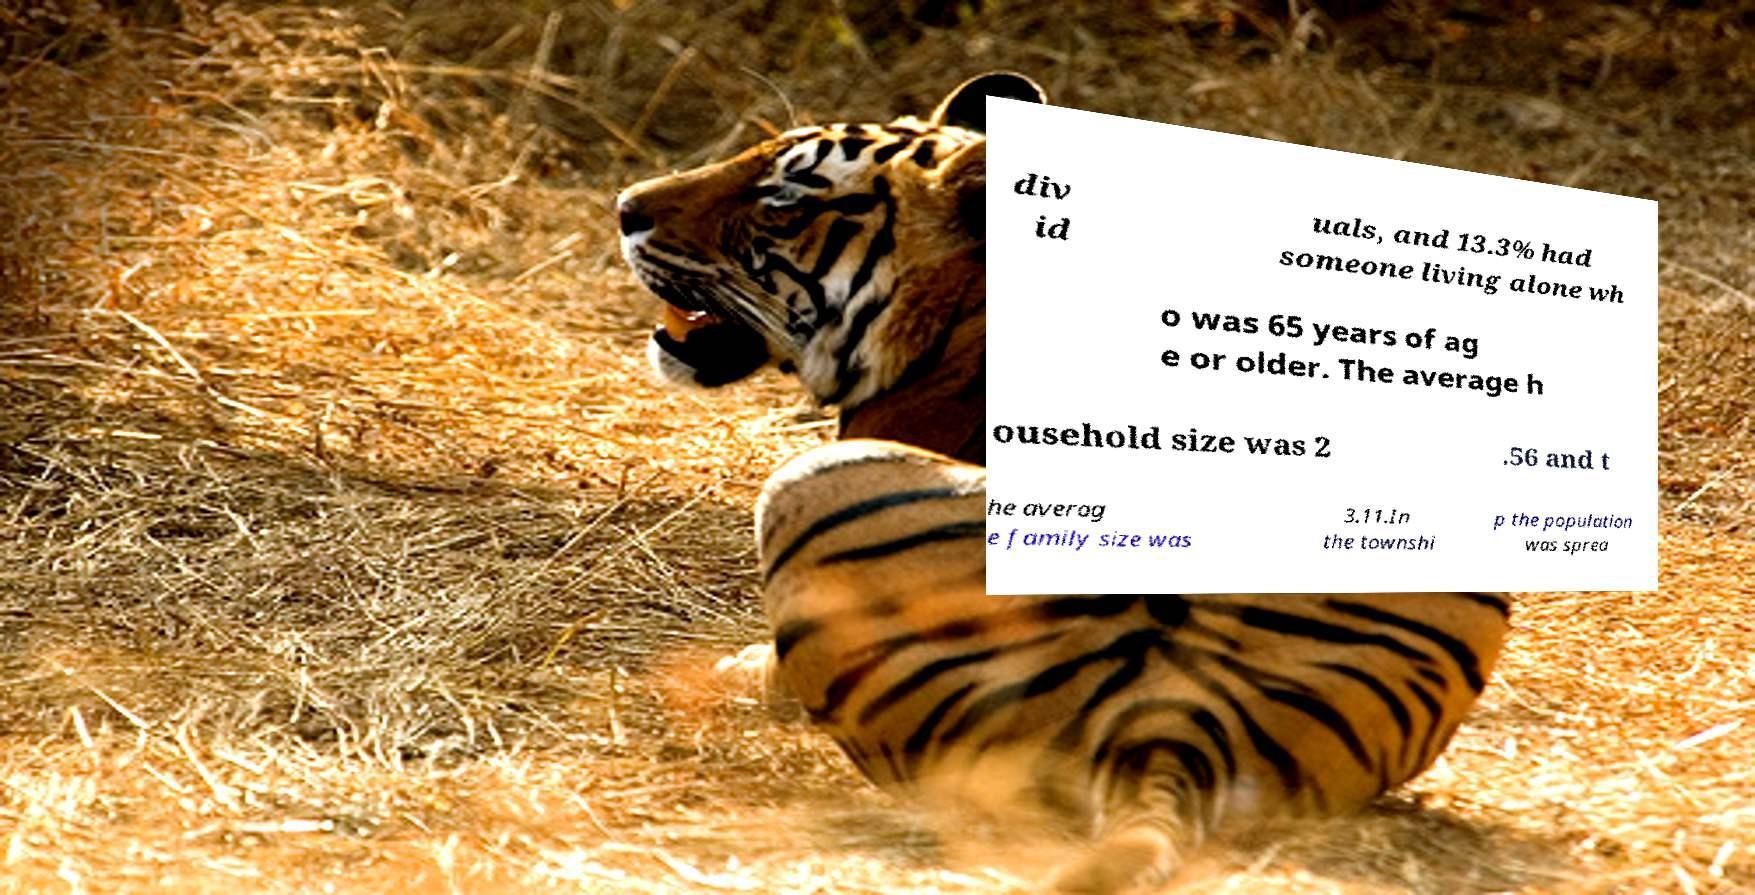Please read and relay the text visible in this image. What does it say? div id uals, and 13.3% had someone living alone wh o was 65 years of ag e or older. The average h ousehold size was 2 .56 and t he averag e family size was 3.11.In the townshi p the population was sprea 